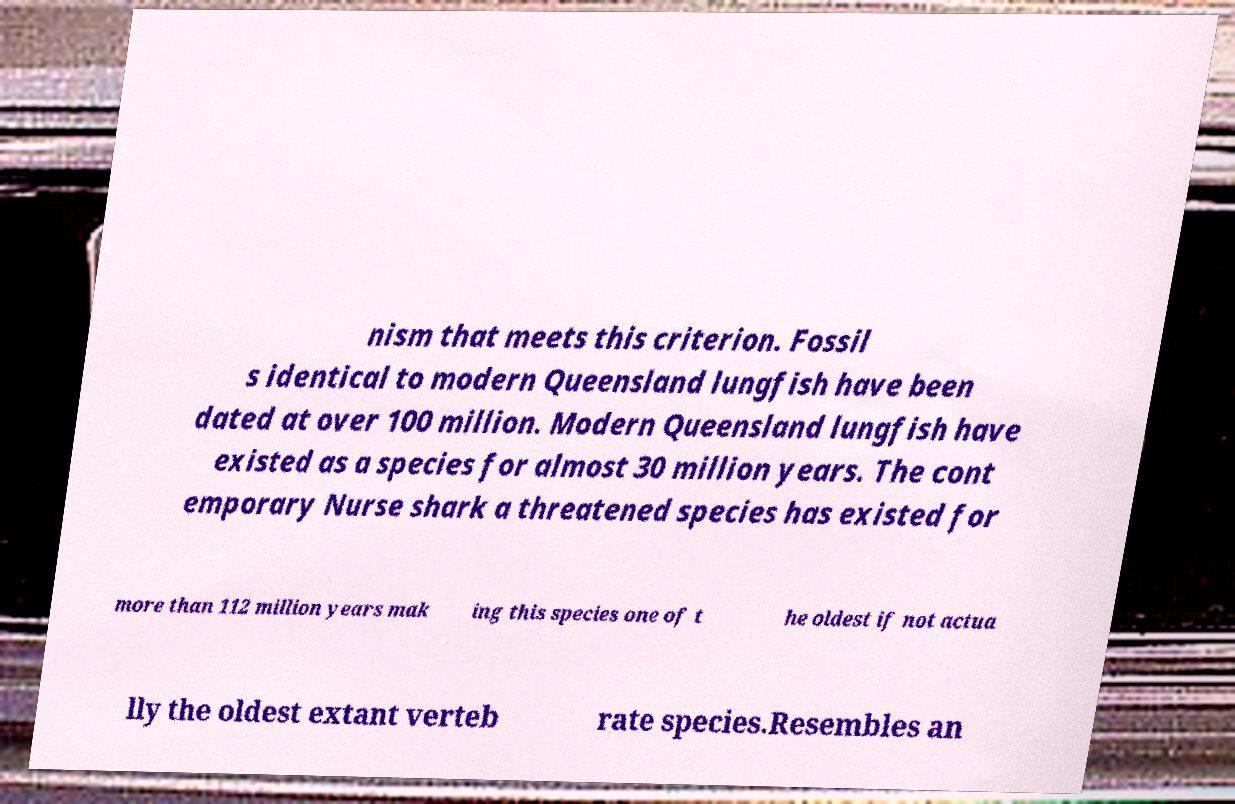Please identify and transcribe the text found in this image. nism that meets this criterion. Fossil s identical to modern Queensland lungfish have been dated at over 100 million. Modern Queensland lungfish have existed as a species for almost 30 million years. The cont emporary Nurse shark a threatened species has existed for more than 112 million years mak ing this species one of t he oldest if not actua lly the oldest extant verteb rate species.Resembles an 